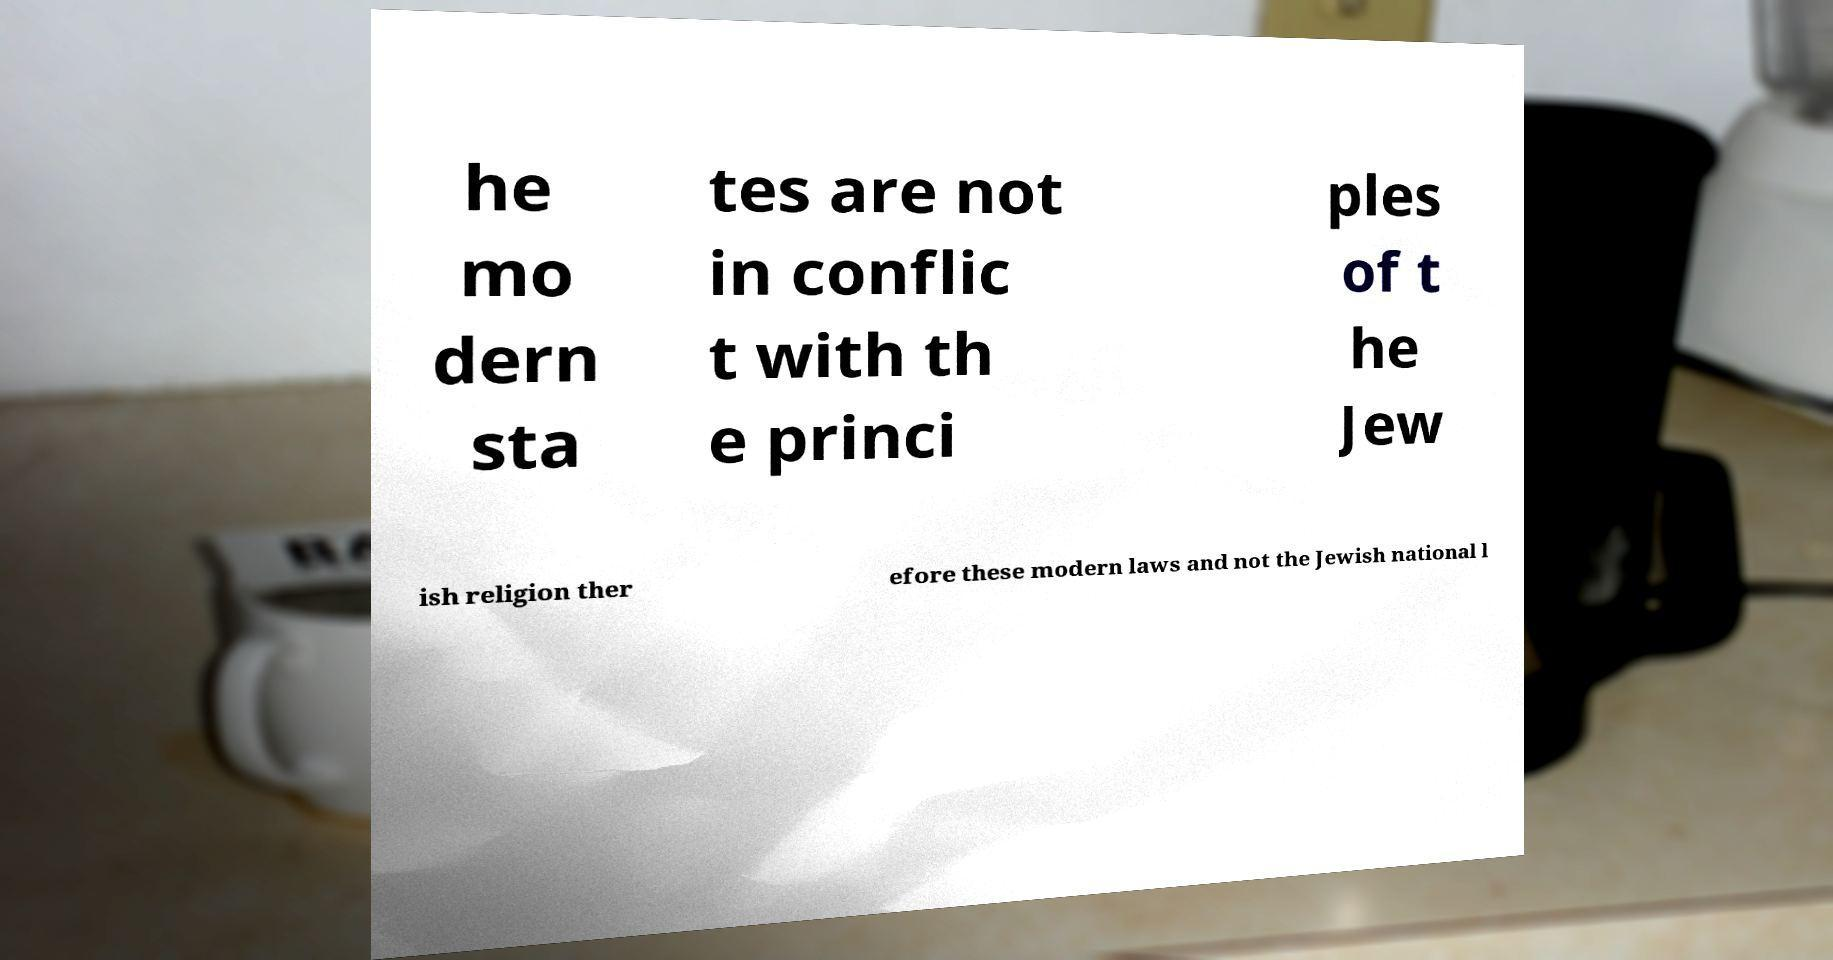There's text embedded in this image that I need extracted. Can you transcribe it verbatim? he mo dern sta tes are not in conflic t with th e princi ples of t he Jew ish religion ther efore these modern laws and not the Jewish national l 